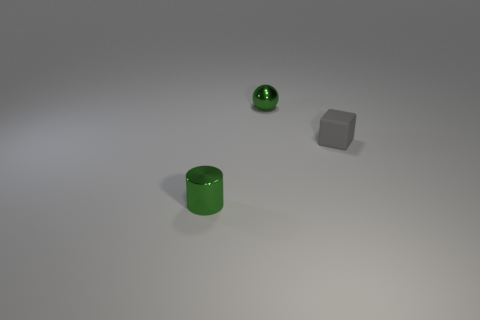Add 1 large blue shiny objects. How many objects exist? 4 Add 3 gray objects. How many gray objects are left? 4 Add 2 brown rubber objects. How many brown rubber objects exist? 2 Subtract 1 green balls. How many objects are left? 2 Subtract all cylinders. How many objects are left? 2 Subtract 1 cylinders. How many cylinders are left? 0 Subtract all brown cylinders. Subtract all brown blocks. How many cylinders are left? 1 Subtract all gray blocks. Subtract all spheres. How many objects are left? 1 